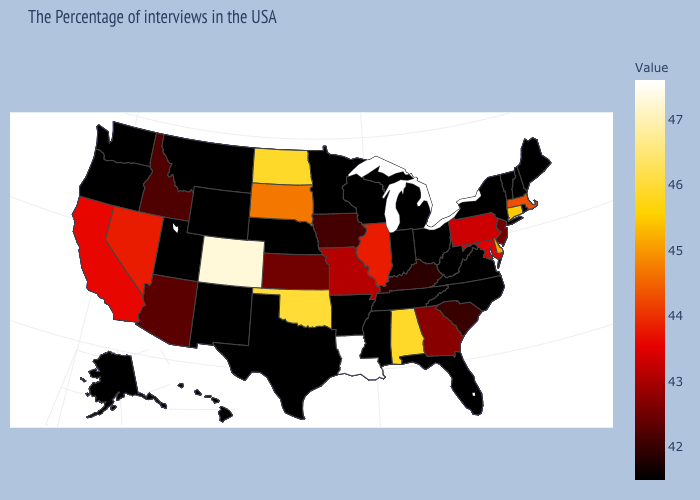Is the legend a continuous bar?
Keep it brief. Yes. Among the states that border Montana , which have the highest value?
Give a very brief answer. North Dakota. Among the states that border Delaware , does Maryland have the highest value?
Write a very short answer. Yes. Does Oregon have a lower value than Delaware?
Write a very short answer. Yes. Does New Jersey have a higher value than Arkansas?
Concise answer only. Yes. 